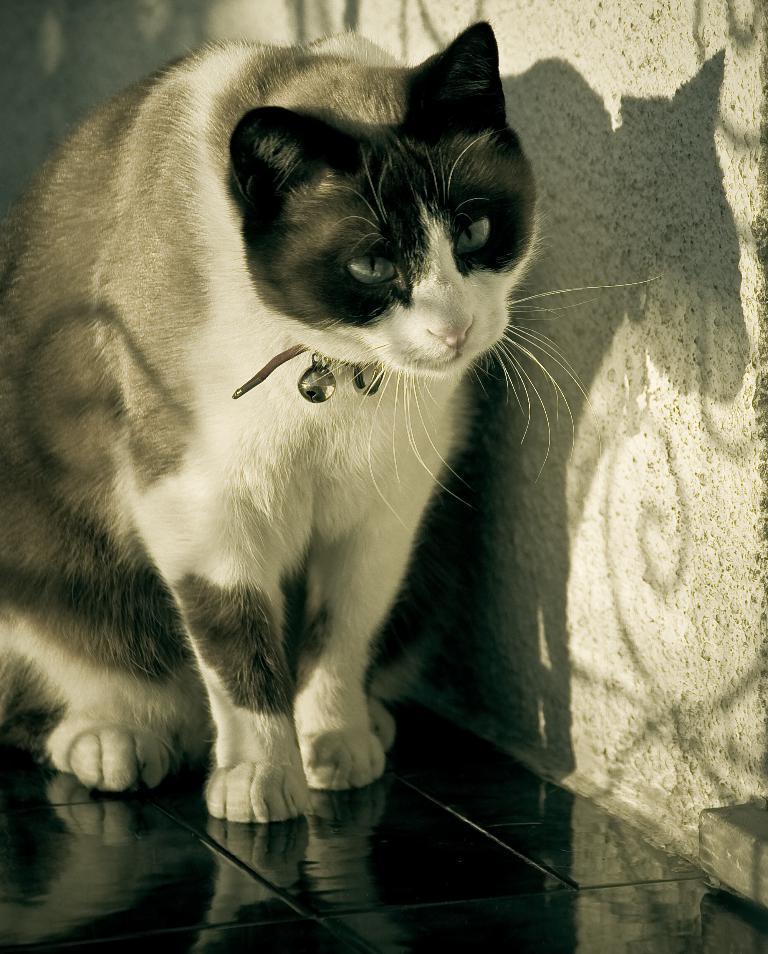How would you summarize this image in a sentence or two? In this picture I can see a cat it is white and black in color and couple of beers to its neck and a wall on the side. 